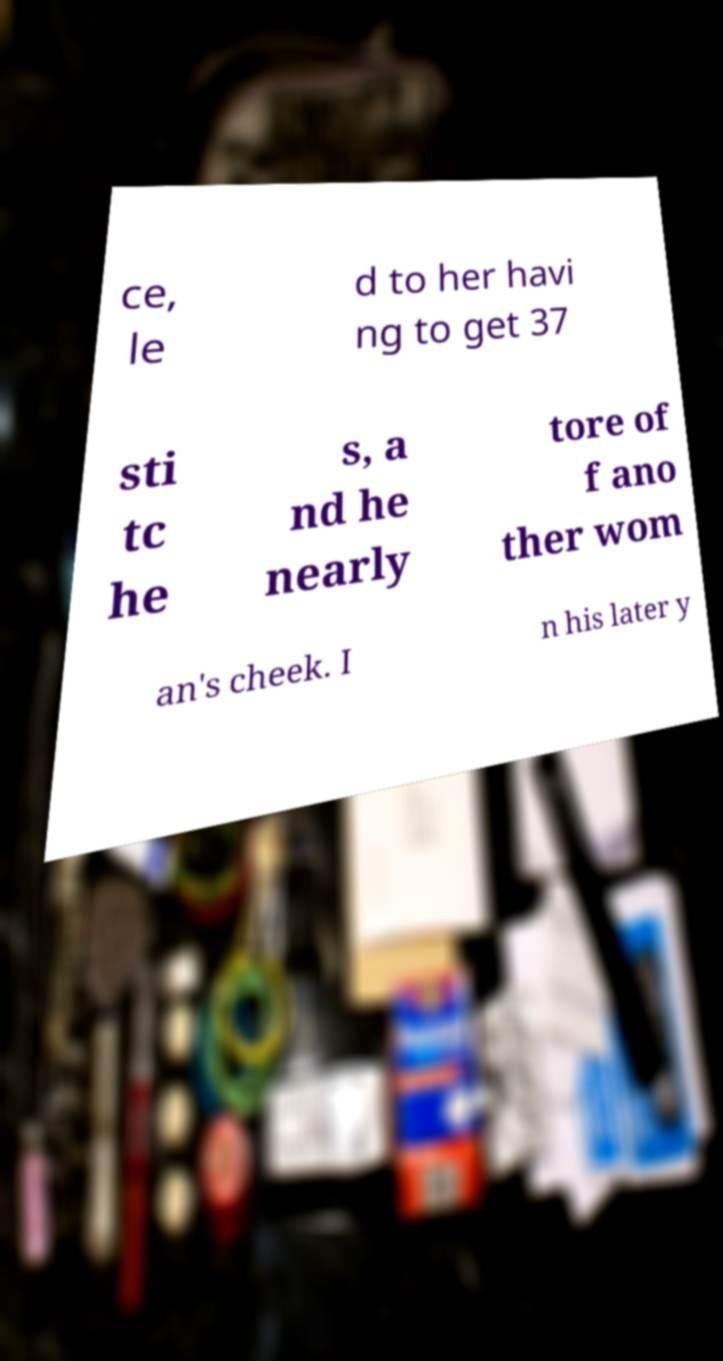Can you read and provide the text displayed in the image?This photo seems to have some interesting text. Can you extract and type it out for me? ce, le d to her havi ng to get 37 sti tc he s, a nd he nearly tore of f ano ther wom an's cheek. I n his later y 